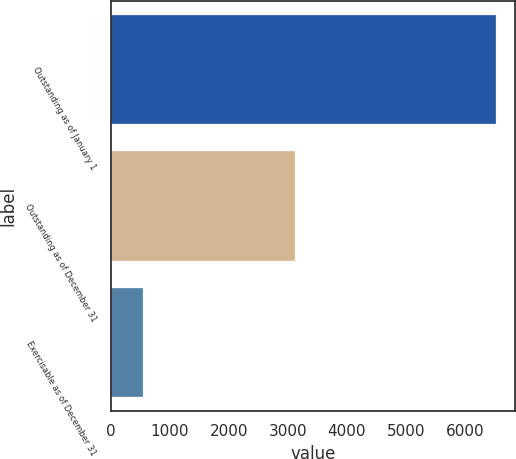Convert chart to OTSL. <chart><loc_0><loc_0><loc_500><loc_500><bar_chart><fcel>Outstanding as of January 1<fcel>Outstanding as of December 31<fcel>Exercisable as of December 31<nl><fcel>6524<fcel>3127<fcel>539<nl></chart> 